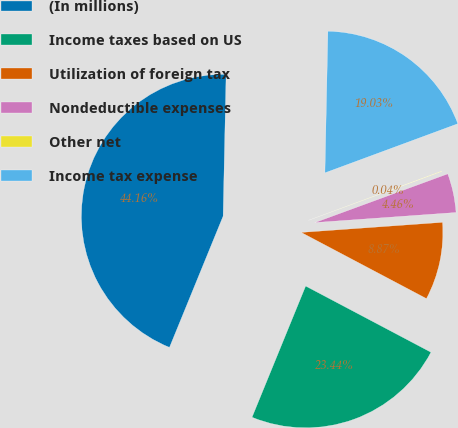Convert chart. <chart><loc_0><loc_0><loc_500><loc_500><pie_chart><fcel>(In millions)<fcel>Income taxes based on US<fcel>Utilization of foreign tax<fcel>Nondeductible expenses<fcel>Other net<fcel>Income tax expense<nl><fcel>44.16%<fcel>23.44%<fcel>8.87%<fcel>4.46%<fcel>0.04%<fcel>19.03%<nl></chart> 